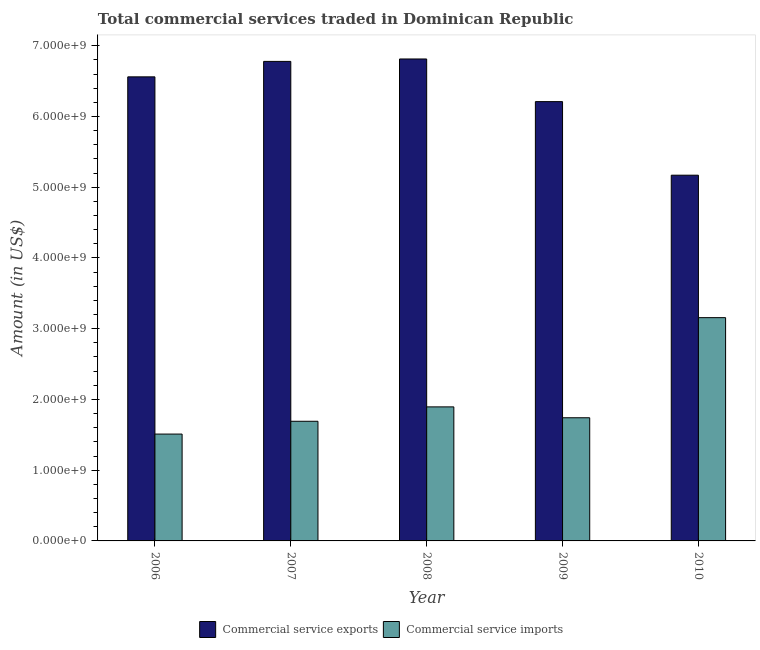How many different coloured bars are there?
Offer a terse response. 2. How many groups of bars are there?
Give a very brief answer. 5. Are the number of bars per tick equal to the number of legend labels?
Give a very brief answer. Yes. Are the number of bars on each tick of the X-axis equal?
Ensure brevity in your answer.  Yes. How many bars are there on the 1st tick from the right?
Your answer should be compact. 2. In how many cases, is the number of bars for a given year not equal to the number of legend labels?
Provide a short and direct response. 0. What is the amount of commercial service imports in 2009?
Offer a very short reply. 1.74e+09. Across all years, what is the maximum amount of commercial service imports?
Ensure brevity in your answer.  3.16e+09. Across all years, what is the minimum amount of commercial service exports?
Offer a very short reply. 5.17e+09. In which year was the amount of commercial service imports maximum?
Make the answer very short. 2010. In which year was the amount of commercial service exports minimum?
Make the answer very short. 2010. What is the total amount of commercial service exports in the graph?
Offer a very short reply. 3.15e+1. What is the difference between the amount of commercial service imports in 2006 and that in 2010?
Keep it short and to the point. -1.65e+09. What is the difference between the amount of commercial service exports in 2007 and the amount of commercial service imports in 2009?
Offer a terse response. 5.69e+08. What is the average amount of commercial service exports per year?
Offer a terse response. 6.31e+09. In the year 2010, what is the difference between the amount of commercial service imports and amount of commercial service exports?
Ensure brevity in your answer.  0. In how many years, is the amount of commercial service exports greater than 1000000000 US$?
Provide a succinct answer. 5. What is the ratio of the amount of commercial service imports in 2007 to that in 2008?
Provide a short and direct response. 0.89. What is the difference between the highest and the second highest amount of commercial service imports?
Offer a terse response. 1.26e+09. What is the difference between the highest and the lowest amount of commercial service imports?
Provide a succinct answer. 1.65e+09. What does the 1st bar from the left in 2008 represents?
Give a very brief answer. Commercial service exports. What does the 2nd bar from the right in 2009 represents?
Offer a terse response. Commercial service exports. How many bars are there?
Make the answer very short. 10. Are all the bars in the graph horizontal?
Your answer should be compact. No. Does the graph contain grids?
Offer a very short reply. No. Where does the legend appear in the graph?
Make the answer very short. Bottom center. How many legend labels are there?
Your answer should be very brief. 2. What is the title of the graph?
Your answer should be compact. Total commercial services traded in Dominican Republic. Does "Fixed telephone" appear as one of the legend labels in the graph?
Your response must be concise. No. What is the label or title of the X-axis?
Your response must be concise. Year. What is the Amount (in US$) of Commercial service exports in 2006?
Ensure brevity in your answer.  6.56e+09. What is the Amount (in US$) in Commercial service imports in 2006?
Give a very brief answer. 1.51e+09. What is the Amount (in US$) of Commercial service exports in 2007?
Offer a terse response. 6.78e+09. What is the Amount (in US$) of Commercial service imports in 2007?
Provide a succinct answer. 1.69e+09. What is the Amount (in US$) of Commercial service exports in 2008?
Ensure brevity in your answer.  6.81e+09. What is the Amount (in US$) of Commercial service imports in 2008?
Keep it short and to the point. 1.89e+09. What is the Amount (in US$) in Commercial service exports in 2009?
Offer a very short reply. 6.21e+09. What is the Amount (in US$) of Commercial service imports in 2009?
Provide a short and direct response. 1.74e+09. What is the Amount (in US$) of Commercial service exports in 2010?
Make the answer very short. 5.17e+09. What is the Amount (in US$) of Commercial service imports in 2010?
Your answer should be very brief. 3.16e+09. Across all years, what is the maximum Amount (in US$) in Commercial service exports?
Your response must be concise. 6.81e+09. Across all years, what is the maximum Amount (in US$) in Commercial service imports?
Your answer should be compact. 3.16e+09. Across all years, what is the minimum Amount (in US$) of Commercial service exports?
Your answer should be very brief. 5.17e+09. Across all years, what is the minimum Amount (in US$) of Commercial service imports?
Keep it short and to the point. 1.51e+09. What is the total Amount (in US$) in Commercial service exports in the graph?
Ensure brevity in your answer.  3.15e+1. What is the total Amount (in US$) of Commercial service imports in the graph?
Your answer should be compact. 9.99e+09. What is the difference between the Amount (in US$) of Commercial service exports in 2006 and that in 2007?
Provide a succinct answer. -2.18e+08. What is the difference between the Amount (in US$) in Commercial service imports in 2006 and that in 2007?
Make the answer very short. -1.81e+08. What is the difference between the Amount (in US$) of Commercial service exports in 2006 and that in 2008?
Make the answer very short. -2.53e+08. What is the difference between the Amount (in US$) in Commercial service imports in 2006 and that in 2008?
Your answer should be compact. -3.84e+08. What is the difference between the Amount (in US$) in Commercial service exports in 2006 and that in 2009?
Make the answer very short. 3.50e+08. What is the difference between the Amount (in US$) in Commercial service imports in 2006 and that in 2009?
Your answer should be compact. -2.31e+08. What is the difference between the Amount (in US$) in Commercial service exports in 2006 and that in 2010?
Your response must be concise. 1.39e+09. What is the difference between the Amount (in US$) of Commercial service imports in 2006 and that in 2010?
Ensure brevity in your answer.  -1.65e+09. What is the difference between the Amount (in US$) of Commercial service exports in 2007 and that in 2008?
Keep it short and to the point. -3.42e+07. What is the difference between the Amount (in US$) of Commercial service imports in 2007 and that in 2008?
Keep it short and to the point. -2.03e+08. What is the difference between the Amount (in US$) of Commercial service exports in 2007 and that in 2009?
Give a very brief answer. 5.69e+08. What is the difference between the Amount (in US$) of Commercial service imports in 2007 and that in 2009?
Make the answer very short. -4.96e+07. What is the difference between the Amount (in US$) of Commercial service exports in 2007 and that in 2010?
Your response must be concise. 1.61e+09. What is the difference between the Amount (in US$) in Commercial service imports in 2007 and that in 2010?
Make the answer very short. -1.46e+09. What is the difference between the Amount (in US$) of Commercial service exports in 2008 and that in 2009?
Offer a very short reply. 6.03e+08. What is the difference between the Amount (in US$) of Commercial service imports in 2008 and that in 2009?
Ensure brevity in your answer.  1.54e+08. What is the difference between the Amount (in US$) in Commercial service exports in 2008 and that in 2010?
Provide a succinct answer. 1.64e+09. What is the difference between the Amount (in US$) in Commercial service imports in 2008 and that in 2010?
Your answer should be very brief. -1.26e+09. What is the difference between the Amount (in US$) in Commercial service exports in 2009 and that in 2010?
Keep it short and to the point. 1.04e+09. What is the difference between the Amount (in US$) of Commercial service imports in 2009 and that in 2010?
Provide a short and direct response. -1.42e+09. What is the difference between the Amount (in US$) in Commercial service exports in 2006 and the Amount (in US$) in Commercial service imports in 2007?
Offer a very short reply. 4.87e+09. What is the difference between the Amount (in US$) of Commercial service exports in 2006 and the Amount (in US$) of Commercial service imports in 2008?
Offer a terse response. 4.67e+09. What is the difference between the Amount (in US$) in Commercial service exports in 2006 and the Amount (in US$) in Commercial service imports in 2009?
Make the answer very short. 4.82e+09. What is the difference between the Amount (in US$) of Commercial service exports in 2006 and the Amount (in US$) of Commercial service imports in 2010?
Provide a short and direct response. 3.40e+09. What is the difference between the Amount (in US$) in Commercial service exports in 2007 and the Amount (in US$) in Commercial service imports in 2008?
Offer a terse response. 4.88e+09. What is the difference between the Amount (in US$) of Commercial service exports in 2007 and the Amount (in US$) of Commercial service imports in 2009?
Give a very brief answer. 5.04e+09. What is the difference between the Amount (in US$) in Commercial service exports in 2007 and the Amount (in US$) in Commercial service imports in 2010?
Offer a very short reply. 3.62e+09. What is the difference between the Amount (in US$) of Commercial service exports in 2008 and the Amount (in US$) of Commercial service imports in 2009?
Give a very brief answer. 5.07e+09. What is the difference between the Amount (in US$) in Commercial service exports in 2008 and the Amount (in US$) in Commercial service imports in 2010?
Provide a succinct answer. 3.66e+09. What is the difference between the Amount (in US$) in Commercial service exports in 2009 and the Amount (in US$) in Commercial service imports in 2010?
Offer a very short reply. 3.05e+09. What is the average Amount (in US$) in Commercial service exports per year?
Your answer should be very brief. 6.31e+09. What is the average Amount (in US$) in Commercial service imports per year?
Provide a succinct answer. 2.00e+09. In the year 2006, what is the difference between the Amount (in US$) in Commercial service exports and Amount (in US$) in Commercial service imports?
Your response must be concise. 5.05e+09. In the year 2007, what is the difference between the Amount (in US$) of Commercial service exports and Amount (in US$) of Commercial service imports?
Your response must be concise. 5.09e+09. In the year 2008, what is the difference between the Amount (in US$) of Commercial service exports and Amount (in US$) of Commercial service imports?
Ensure brevity in your answer.  4.92e+09. In the year 2009, what is the difference between the Amount (in US$) in Commercial service exports and Amount (in US$) in Commercial service imports?
Ensure brevity in your answer.  4.47e+09. In the year 2010, what is the difference between the Amount (in US$) in Commercial service exports and Amount (in US$) in Commercial service imports?
Offer a terse response. 2.01e+09. What is the ratio of the Amount (in US$) of Commercial service exports in 2006 to that in 2007?
Provide a succinct answer. 0.97. What is the ratio of the Amount (in US$) of Commercial service imports in 2006 to that in 2007?
Provide a short and direct response. 0.89. What is the ratio of the Amount (in US$) in Commercial service exports in 2006 to that in 2008?
Offer a very short reply. 0.96. What is the ratio of the Amount (in US$) in Commercial service imports in 2006 to that in 2008?
Offer a very short reply. 0.8. What is the ratio of the Amount (in US$) in Commercial service exports in 2006 to that in 2009?
Make the answer very short. 1.06. What is the ratio of the Amount (in US$) in Commercial service imports in 2006 to that in 2009?
Your answer should be compact. 0.87. What is the ratio of the Amount (in US$) of Commercial service exports in 2006 to that in 2010?
Provide a succinct answer. 1.27. What is the ratio of the Amount (in US$) in Commercial service imports in 2006 to that in 2010?
Offer a terse response. 0.48. What is the ratio of the Amount (in US$) of Commercial service exports in 2007 to that in 2008?
Give a very brief answer. 0.99. What is the ratio of the Amount (in US$) of Commercial service imports in 2007 to that in 2008?
Provide a succinct answer. 0.89. What is the ratio of the Amount (in US$) in Commercial service exports in 2007 to that in 2009?
Your answer should be very brief. 1.09. What is the ratio of the Amount (in US$) of Commercial service imports in 2007 to that in 2009?
Keep it short and to the point. 0.97. What is the ratio of the Amount (in US$) in Commercial service exports in 2007 to that in 2010?
Give a very brief answer. 1.31. What is the ratio of the Amount (in US$) of Commercial service imports in 2007 to that in 2010?
Offer a very short reply. 0.54. What is the ratio of the Amount (in US$) in Commercial service exports in 2008 to that in 2009?
Your answer should be compact. 1.1. What is the ratio of the Amount (in US$) in Commercial service imports in 2008 to that in 2009?
Offer a very short reply. 1.09. What is the ratio of the Amount (in US$) of Commercial service exports in 2008 to that in 2010?
Make the answer very short. 1.32. What is the ratio of the Amount (in US$) in Commercial service imports in 2008 to that in 2010?
Your answer should be very brief. 0.6. What is the ratio of the Amount (in US$) of Commercial service exports in 2009 to that in 2010?
Give a very brief answer. 1.2. What is the ratio of the Amount (in US$) in Commercial service imports in 2009 to that in 2010?
Offer a very short reply. 0.55. What is the difference between the highest and the second highest Amount (in US$) of Commercial service exports?
Provide a succinct answer. 3.42e+07. What is the difference between the highest and the second highest Amount (in US$) in Commercial service imports?
Your answer should be compact. 1.26e+09. What is the difference between the highest and the lowest Amount (in US$) of Commercial service exports?
Provide a succinct answer. 1.64e+09. What is the difference between the highest and the lowest Amount (in US$) of Commercial service imports?
Ensure brevity in your answer.  1.65e+09. 